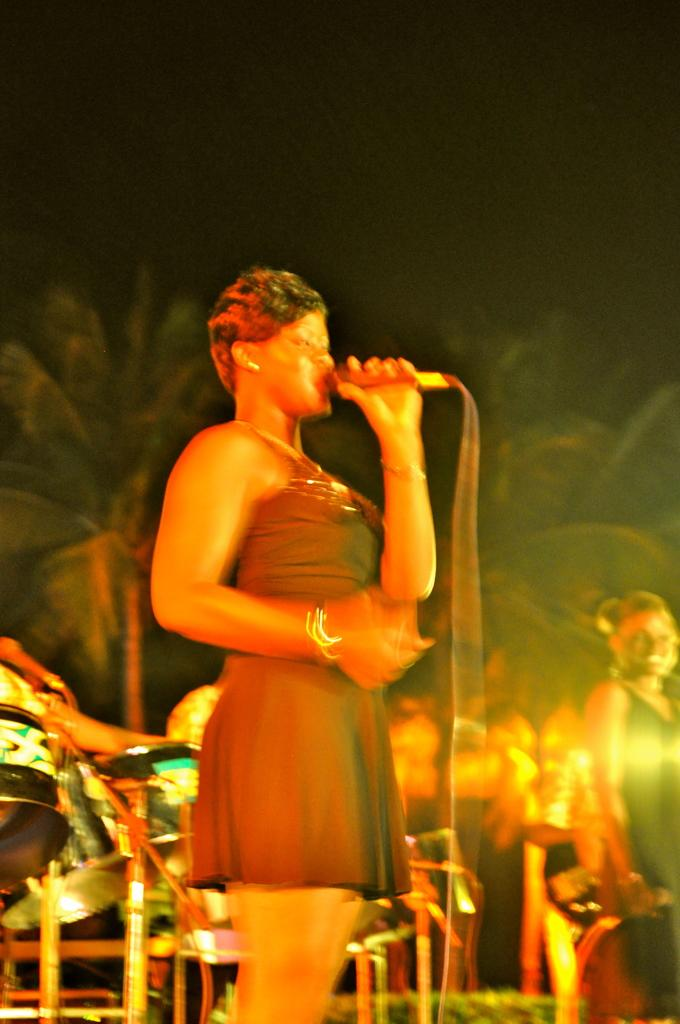What is the main subject of the image? The main subject of the image is a woman. What is the woman doing in the image? The woman is standing and singing in the image. What else can be seen in the image besides the woman? There are music equipment and other people in the image. What is visible in the background of the image? There are trees in the background of the image. How many visitors can be seen in the image? There are no visitors present in the image. 